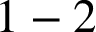Convert formula to latex. <formula><loc_0><loc_0><loc_500><loc_500>1 - 2</formula> 